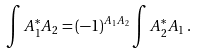Convert formula to latex. <formula><loc_0><loc_0><loc_500><loc_500>\int A _ { 1 } ^ { * } A _ { 2 } = ( - 1 ) ^ { A _ { 1 } A _ { 2 } } \int A _ { 2 } ^ { * } A _ { 1 } \, .</formula> 